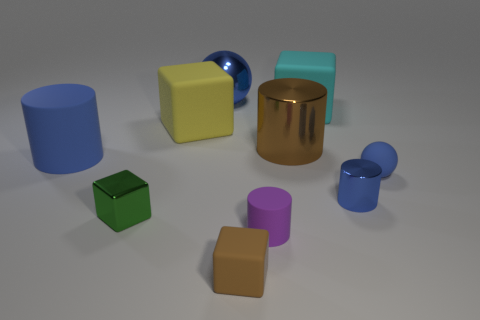What shape is the brown object that is in front of the blue shiny object in front of the large shiny ball?
Provide a short and direct response. Cube. There is a small matte object that is the same shape as the brown metal object; what color is it?
Your answer should be very brief. Purple. There is a brown object that is in front of the blue rubber sphere; does it have the same size as the large blue metal thing?
Offer a very short reply. No. There is a rubber object that is the same color as the tiny matte sphere; what is its shape?
Offer a very short reply. Cylinder. How many big blue cylinders are made of the same material as the green cube?
Provide a succinct answer. 0. What is the material of the blue ball that is to the right of the tiny shiny object that is to the right of the blue metallic thing that is to the left of the small brown object?
Make the answer very short. Rubber. The rubber cylinder that is behind the blue rubber thing that is in front of the large blue cylinder is what color?
Provide a short and direct response. Blue. There is a rubber cylinder that is the same size as the blue matte sphere; what is its color?
Keep it short and to the point. Purple. What number of small objects are either blue matte cylinders or green metallic cylinders?
Offer a very short reply. 0. Is the number of things that are in front of the large rubber cylinder greater than the number of purple things that are right of the cyan matte block?
Offer a terse response. Yes. 